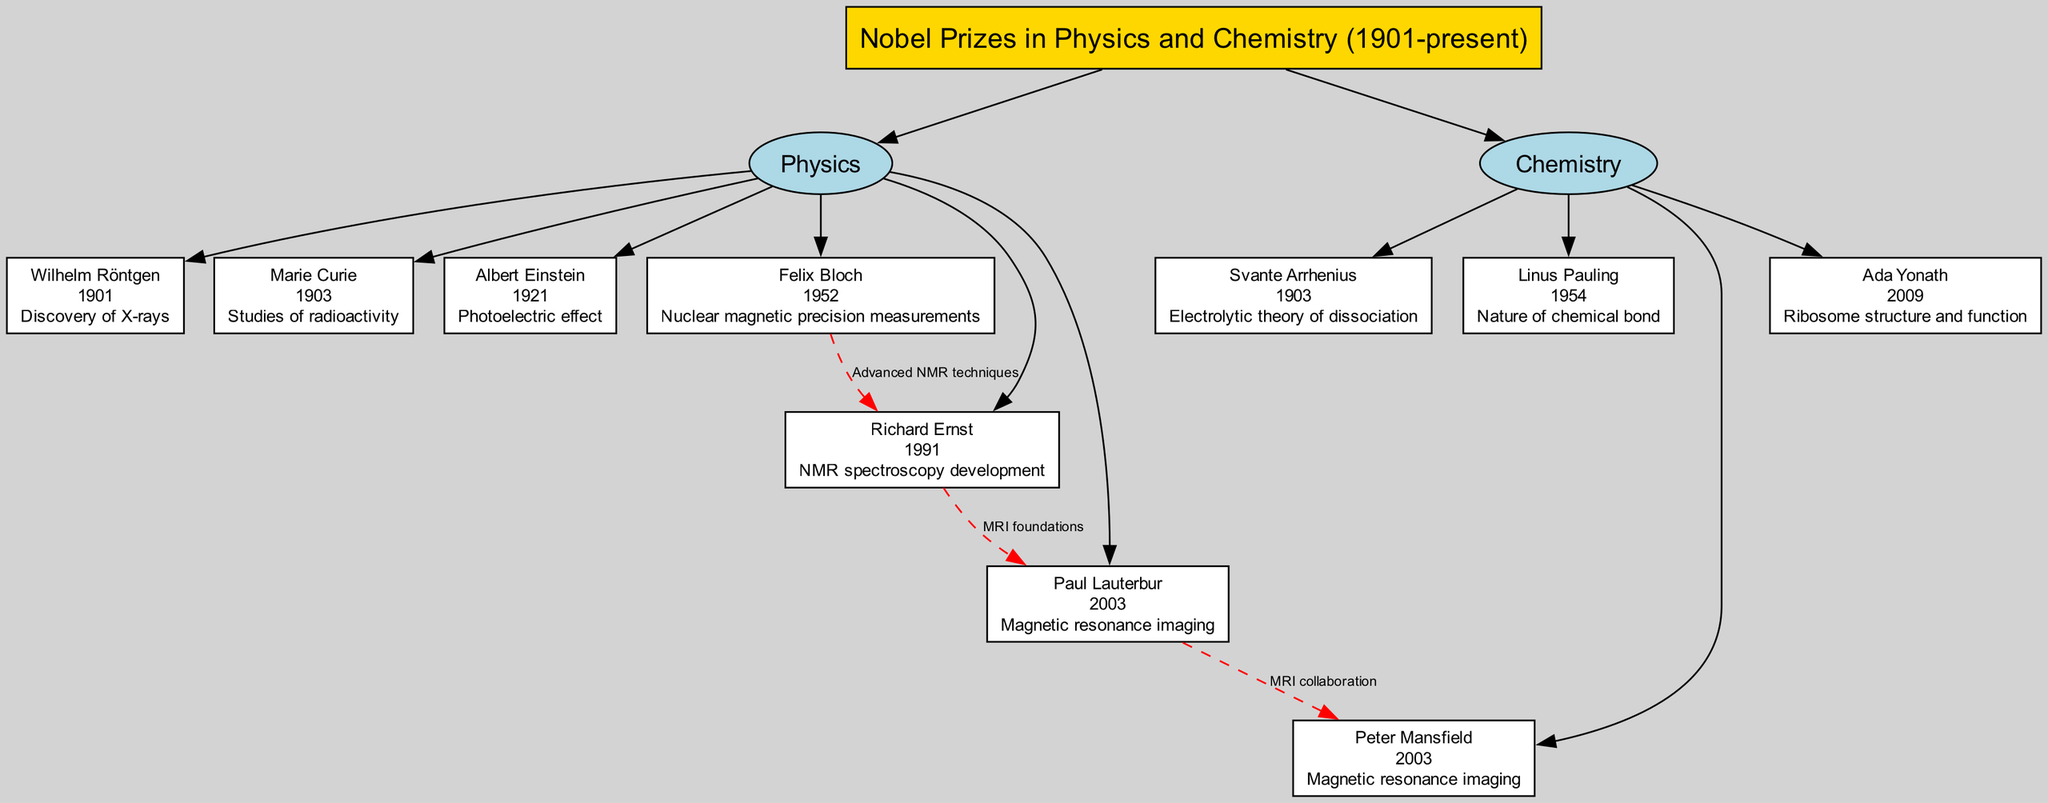What year did Wilhelm Röntgen win the Nobel Prize? The diagram states that Wilhelm Röntgen won the Nobel Prize in Physics in 1901, which is clearly indicated in his node.
Answer: 1901 Who won the Nobel Prize in Chemistry in 2009? According to the diagram, the node for Ada Yonath in the Chemistry branch indicates she won the Nobel Prize in Chemistry in 2009.
Answer: Ada Yonath What achievement is associated with Marie Curie? The diagram specifies that Marie Curie's achievement is the studies of radioactivity, directly listed in her node next to her name and year.
Answer: Studies of radioactivity Which two scientists are connected through advanced NMR techniques? The connection from Felix Bloch to Richard Ernst labeled as "Advanced NMR techniques" indicates the relationship between these two scientists based on their contributions to NMR.
Answer: Felix Bloch and Richard Ernst How many nodes are there in the Chemistry branch? The Chemistry branch contains four nodes: Svante Arrhenius, Linus Pauling, Peter Mansfield, and Ada Yonath, which are easily counted in the diagram.
Answer: 4 What is the relationship between Richard Ernst and Paul Lauterbur? The diagram shows a connection between Richard Ernst and Paul Lauterbur labeled "MRI foundations," indicating their collaborative relationship related to MRI technology.
Answer: MRI foundations Who collaborated with Paul Lauterbur on MRI? The connection labeled "MRI collaboration" from Paul Lauterbur to Peter Mansfield shows that Peter Mansfield collaborated with Paul Lauterbur on MRI.
Answer: Peter Mansfield What notable discovery did Albert Einstein achieve? The diagram highlights Albert Einstein's achievement as the photoelectric effect, which is clearly noted in his node.
Answer: Photoelectric effect Which prize did Peter Mansfield win in 2003? The node for Peter Mansfield in the Chemistry branch states he won the Nobel Prize for magnetic resonance imaging in 2003, which identifies the specific prize and year.
Answer: Magnetic resonance imaging 